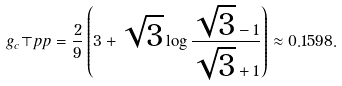Convert formula to latex. <formula><loc_0><loc_0><loc_500><loc_500>g _ { c } \top p { p } = \frac { 2 } { 9 } \left ( 3 + \sqrt { 3 } \log \frac { \sqrt { 3 } - 1 } { \sqrt { 3 } + 1 } \right ) \approx 0 . 1 5 9 8 .</formula> 